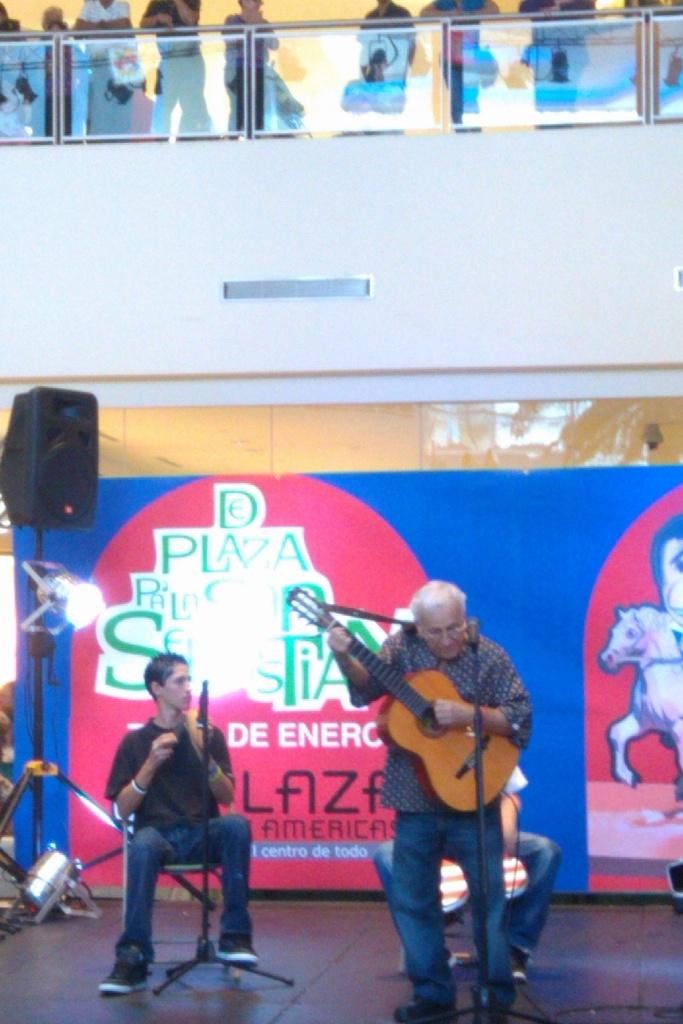What is the man in the image doing while seated on a chair? There is no man seated on a chair in the image. What is the man in the image doing? The man in the image is playing a guitar. What is placed in front of the man playing the guitar? A microphone is present in front of the man playing the guitar. Where are the other people in the image located? There is a group of people standing on the top stairs in the image. What type of doctor is the man playing the guitar in the image? There is no doctor present in the image; the man is playing a guitar. What are the hobbies of the people standing on the top stairs in the image? There is no information about the hobbies of the people standing on the top stairs in the image. 